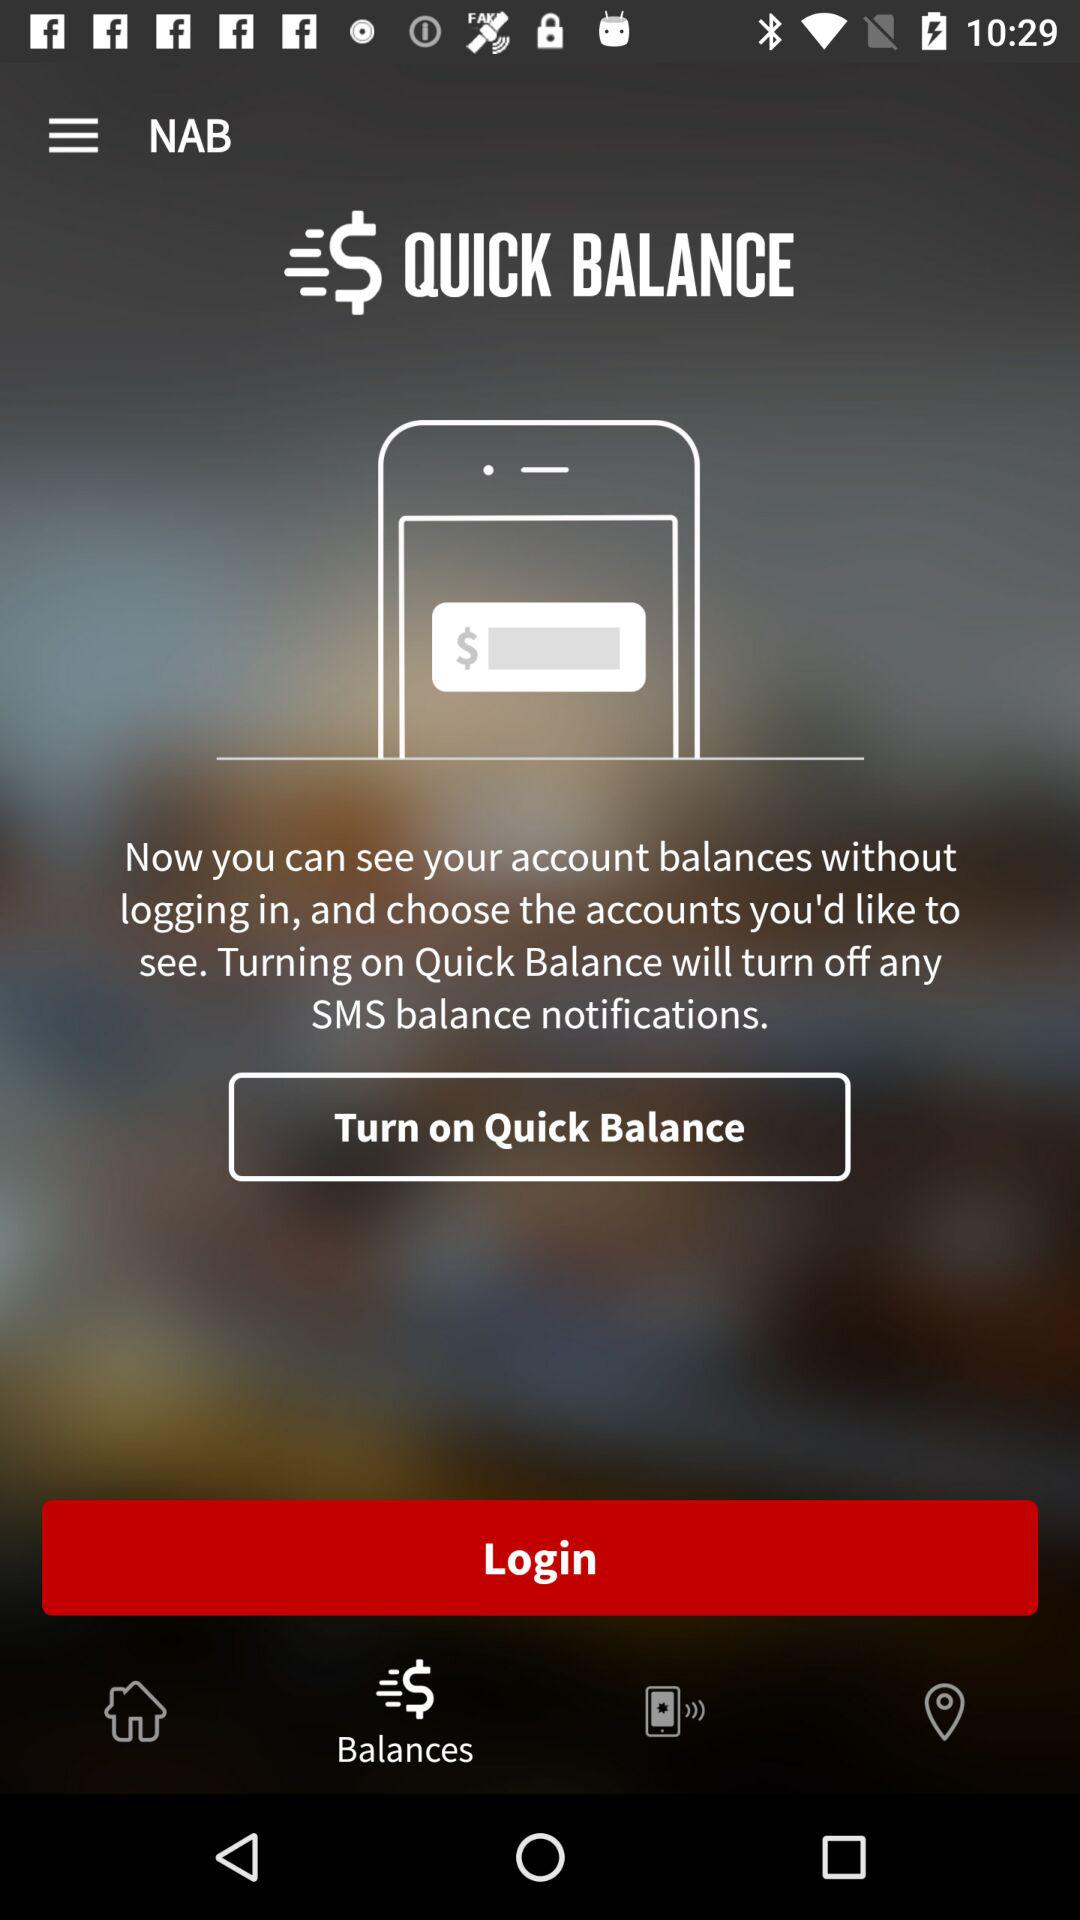What is the name of the application? The name of the application is "NAB". 